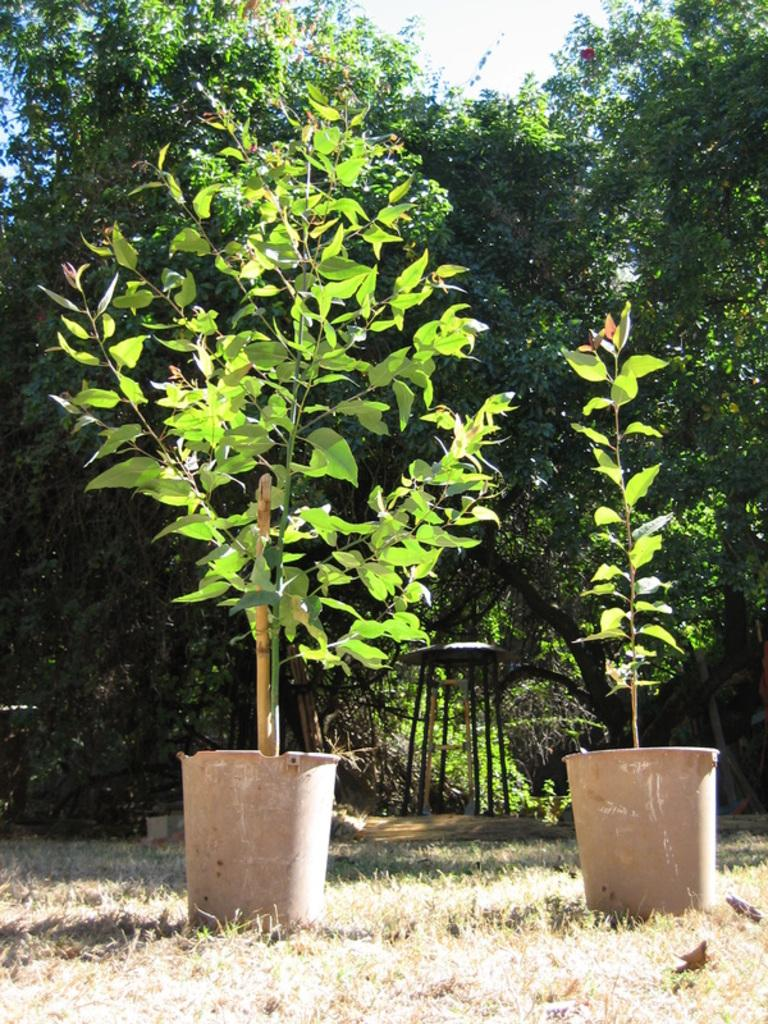What is the object on the ground in the image? The facts do not specify the object on the ground, so we cannot definitively answer this question. What type of vegetation is visible in the image? There is grass, flower pots, and trees visible in the image. Where are the flower pots located in the image? The facts do not specify the location of the flower pots, so we cannot definitively answer this question. What is visible in the sky in the image? The sky is visible in the image, but the facts do not specify any details about the sky. Can you hear the harmony of the coach playing the trumpet in the image? There is no coach, trumpet, or any sound mentioned in the image, so we cannot answer this question. 